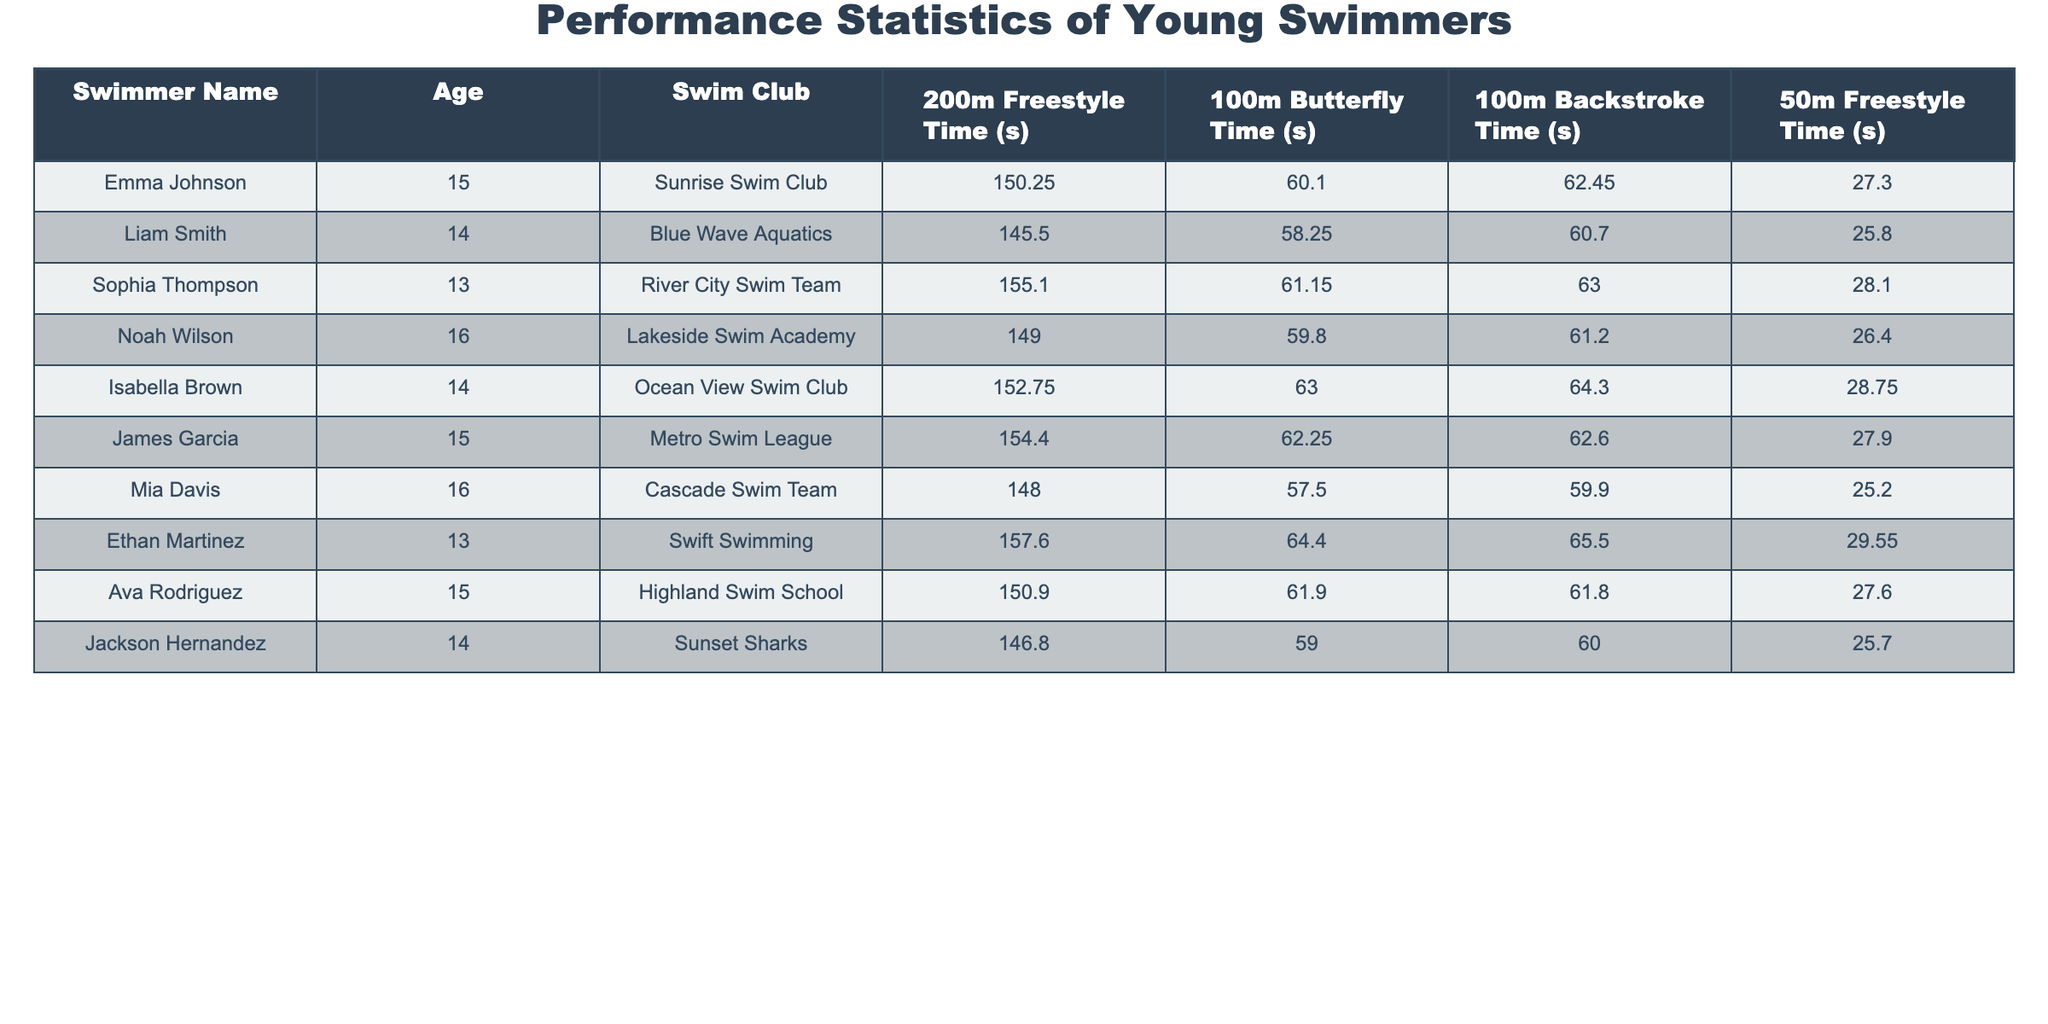What is the fastest 200m freestyle time recorded in the table? The 200m freestyle times are listed for each swimmer. Scanning through the times, Liam Smith has the fastest time at 145.50 seconds.
Answer: 145.50 seconds How old is Mia Davis? Mia Davis is listed in the table with an age of 16.
Answer: 16 Which swimmer belongs to the Ocean View Swim Club? By checking the Swim Club column, Isabella Brown is the swimmer affiliated with the Ocean View Swim Club.
Answer: Isabella Brown What is the average time for the 100m Butterfly among the swimmers? The 100m Butterfly times are 60.10, 58.25, 61.15, 59.80, 63.00, 62.25, 57.50, 64.40, 61.90, and 59.00. Adding these gives a total of 613.35 seconds. There are 10 swimmers, so the average is 613.35/10 = 61.34 seconds.
Answer: 61.34 seconds Is there a swimmer aged 13 with a faster 50m freestyle time than 27 seconds? Ethan Martinez is 13 years old and has a 50m freestyle time of 29.55 seconds. He is slower than 27 seconds, while Liam Smith, aged 14, has a time of 25.80 seconds. Therefore, Ethan does not meet the criteria.
Answer: No Who has the slowest 100m Backstroke time in the table? The 100m Backstroke times are listed as 62.45, 60.70, 63.00, 61.20, 64.30, 62.60, 59.90, 65.50, 61.80, and 60.00. By identifying the maximum time, Ethan Martinez has the slowest time of 65.50 seconds.
Answer: Ethan Martinez What is the difference between the fastest and slowest 50m freestyle times? The fastest 50m freestyle time is 25.20 seconds (Mia Davis), and the slowest is 29.55 seconds (Ethan Martinez). The difference is 29.55 - 25.20 = 4.35 seconds.
Answer: 4.35 seconds Which swimmer has the best overall performance across all events? To determine the best overall performance, we look at the best times across each event for each swimmer. Mia Davis has the most competitive times with the fastest 50m and 100m butterfly and competitive freestyle times which suggests she has the better overall performance.
Answer: Mia Davis Is there a swimmer older than 15 with a 200m freestyle time below 150 seconds? Noah Wilson (16 years old) and Mia Davis (16 years old) are both over 15. Their 200m freestyle times are 149.00 and 148.00 seconds respectively, both are below 150.
Answer: Yes 